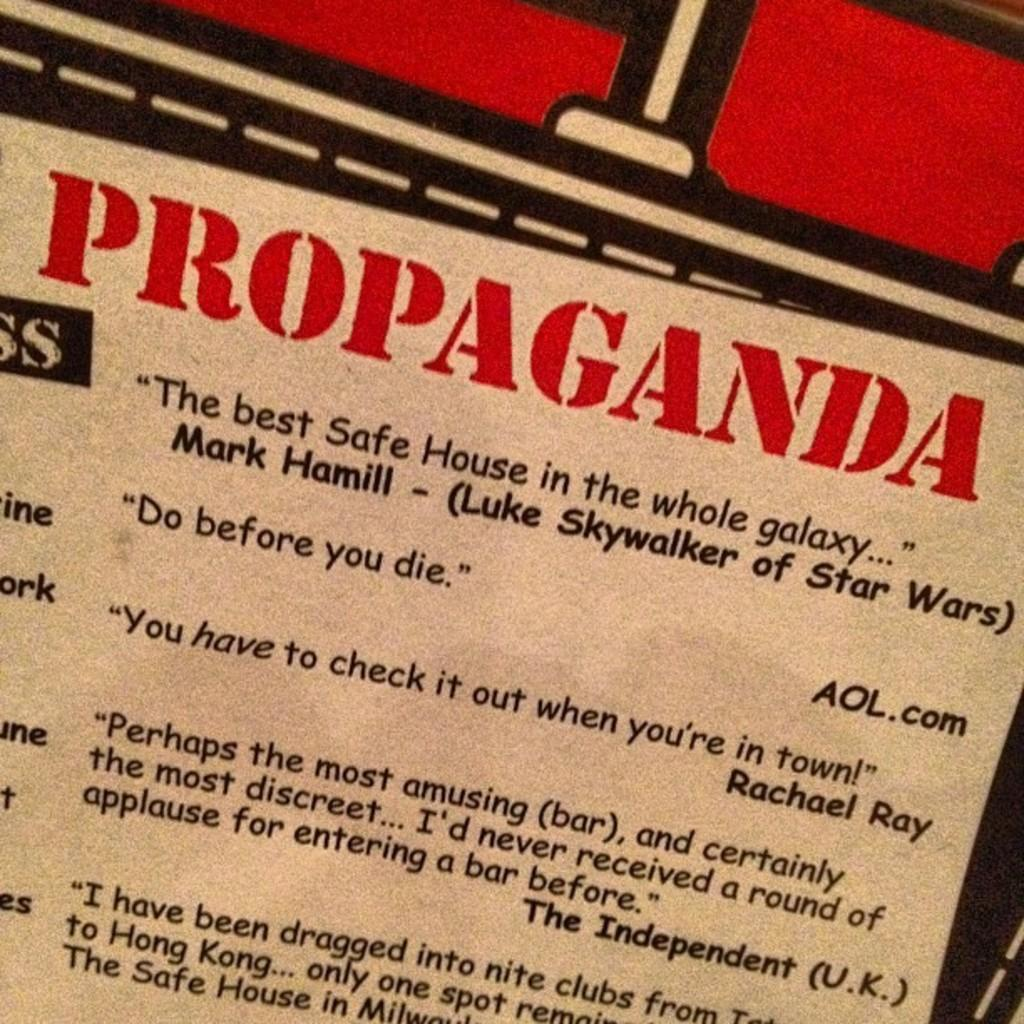Provide a one-sentence caption for the provided image. A sign that says "Propaganda" on it and a bunch of quotes. 